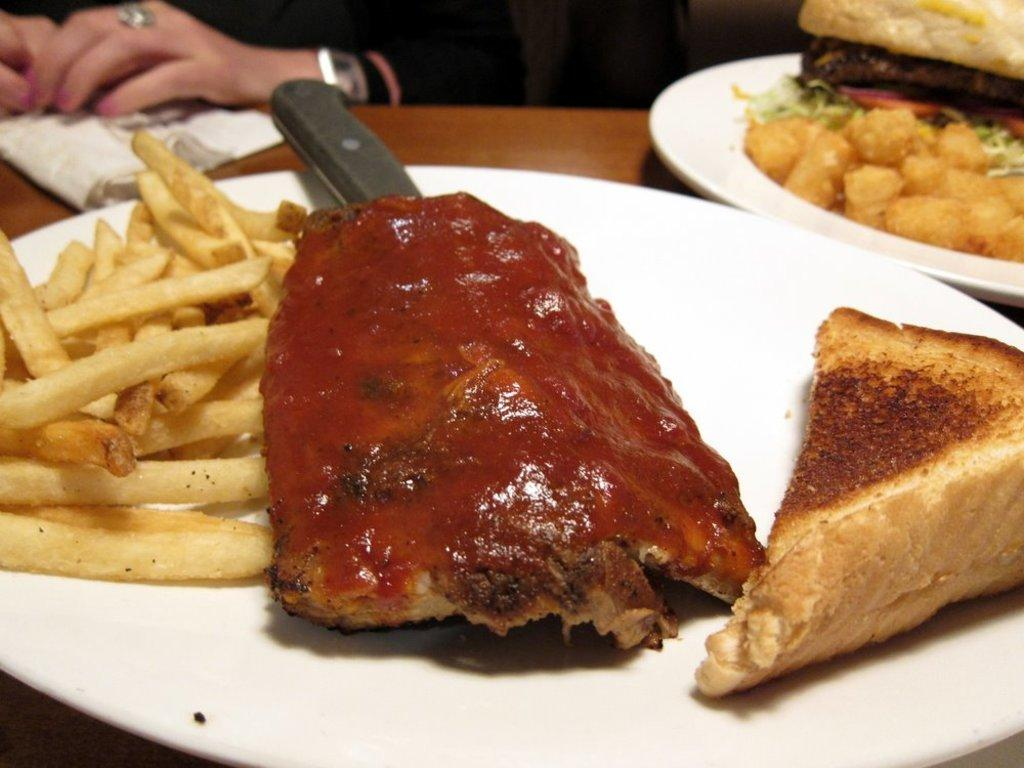What type of food can be seen in the image? The image contains food, specifically french fries, meat, and bread. How are the food items arranged in the image? The food items are arranged on a plate in the image. What utensil is present on the plate? A knife is present on the plate. Can you describe the person in the background of the image? There is a person sitting in the background of the image. What type of sand can be seen in the image? There is no sand present in the image. How many passengers are visible in the image? There is no reference to passengers in the image; it features food and a person sitting in the background. 